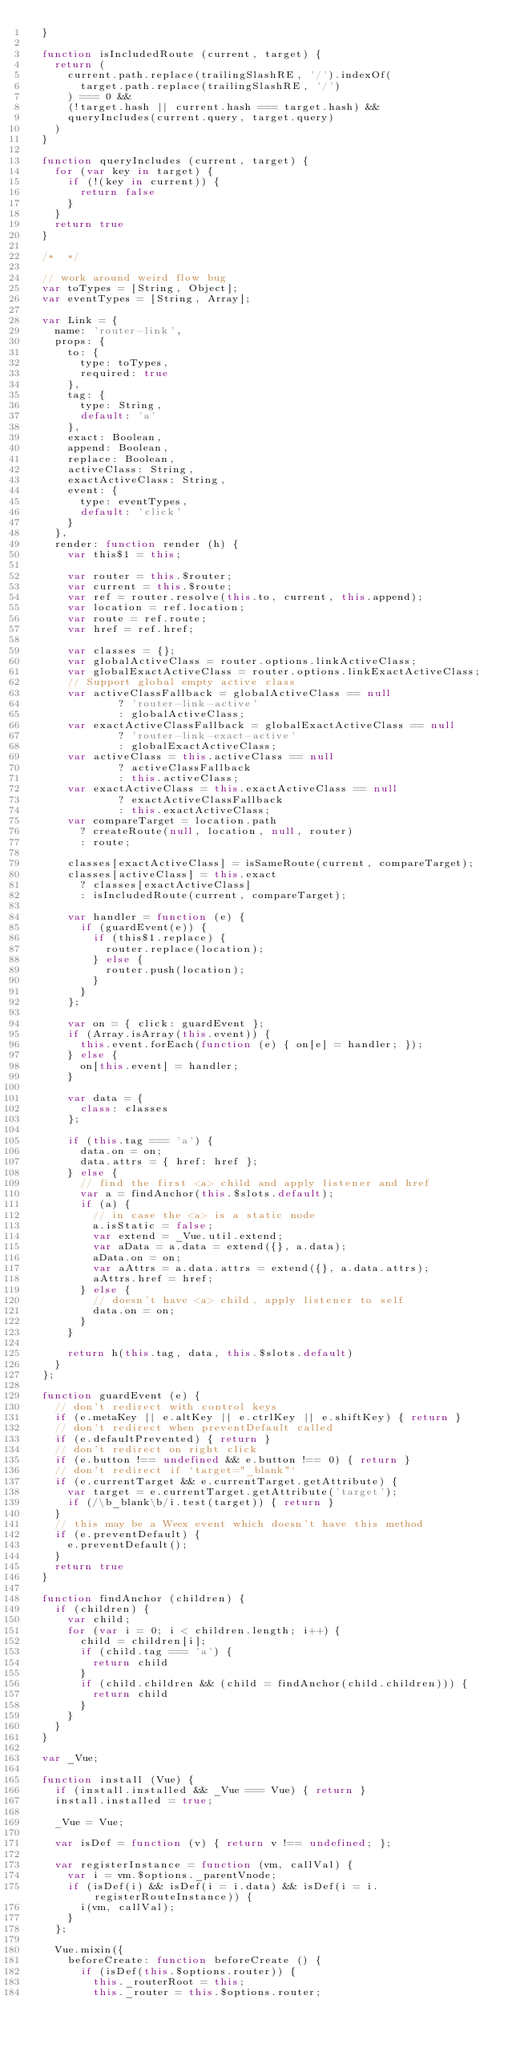<code> <loc_0><loc_0><loc_500><loc_500><_JavaScript_>  }
  
  function isIncludedRoute (current, target) {
    return (
      current.path.replace(trailingSlashRE, '/').indexOf(
        target.path.replace(trailingSlashRE, '/')
      ) === 0 &&
      (!target.hash || current.hash === target.hash) &&
      queryIncludes(current.query, target.query)
    )
  }
  
  function queryIncludes (current, target) {
    for (var key in target) {
      if (!(key in current)) {
        return false
      }
    }
    return true
  }
  
  /*  */
  
  // work around weird flow bug
  var toTypes = [String, Object];
  var eventTypes = [String, Array];
  
  var Link = {
    name: 'router-link',
    props: {
      to: {
        type: toTypes,
        required: true
      },
      tag: {
        type: String,
        default: 'a'
      },
      exact: Boolean,
      append: Boolean,
      replace: Boolean,
      activeClass: String,
      exactActiveClass: String,
      event: {
        type: eventTypes,
        default: 'click'
      }
    },
    render: function render (h) {
      var this$1 = this;
  
      var router = this.$router;
      var current = this.$route;
      var ref = router.resolve(this.to, current, this.append);
      var location = ref.location;
      var route = ref.route;
      var href = ref.href;
  
      var classes = {};
      var globalActiveClass = router.options.linkActiveClass;
      var globalExactActiveClass = router.options.linkExactActiveClass;
      // Support global empty active class
      var activeClassFallback = globalActiveClass == null
              ? 'router-link-active'
              : globalActiveClass;
      var exactActiveClassFallback = globalExactActiveClass == null
              ? 'router-link-exact-active'
              : globalExactActiveClass;
      var activeClass = this.activeClass == null
              ? activeClassFallback
              : this.activeClass;
      var exactActiveClass = this.exactActiveClass == null
              ? exactActiveClassFallback
              : this.exactActiveClass;
      var compareTarget = location.path
        ? createRoute(null, location, null, router)
        : route;
  
      classes[exactActiveClass] = isSameRoute(current, compareTarget);
      classes[activeClass] = this.exact
        ? classes[exactActiveClass]
        : isIncludedRoute(current, compareTarget);
  
      var handler = function (e) {
        if (guardEvent(e)) {
          if (this$1.replace) {
            router.replace(location);
          } else {
            router.push(location);
          }
        }
      };
  
      var on = { click: guardEvent };
      if (Array.isArray(this.event)) {
        this.event.forEach(function (e) { on[e] = handler; });
      } else {
        on[this.event] = handler;
      }
  
      var data = {
        class: classes
      };
  
      if (this.tag === 'a') {
        data.on = on;
        data.attrs = { href: href };
      } else {
        // find the first <a> child and apply listener and href
        var a = findAnchor(this.$slots.default);
        if (a) {
          // in case the <a> is a static node
          a.isStatic = false;
          var extend = _Vue.util.extend;
          var aData = a.data = extend({}, a.data);
          aData.on = on;
          var aAttrs = a.data.attrs = extend({}, a.data.attrs);
          aAttrs.href = href;
        } else {
          // doesn't have <a> child, apply listener to self
          data.on = on;
        }
      }
  
      return h(this.tag, data, this.$slots.default)
    }
  };
  
  function guardEvent (e) {
    // don't redirect with control keys
    if (e.metaKey || e.altKey || e.ctrlKey || e.shiftKey) { return }
    // don't redirect when preventDefault called
    if (e.defaultPrevented) { return }
    // don't redirect on right click
    if (e.button !== undefined && e.button !== 0) { return }
    // don't redirect if `target="_blank"`
    if (e.currentTarget && e.currentTarget.getAttribute) {
      var target = e.currentTarget.getAttribute('target');
      if (/\b_blank\b/i.test(target)) { return }
    }
    // this may be a Weex event which doesn't have this method
    if (e.preventDefault) {
      e.preventDefault();
    }
    return true
  }
  
  function findAnchor (children) {
    if (children) {
      var child;
      for (var i = 0; i < children.length; i++) {
        child = children[i];
        if (child.tag === 'a') {
          return child
        }
        if (child.children && (child = findAnchor(child.children))) {
          return child
        }
      }
    }
  }
  
  var _Vue;
  
  function install (Vue) {
    if (install.installed && _Vue === Vue) { return }
    install.installed = true;
  
    _Vue = Vue;
  
    var isDef = function (v) { return v !== undefined; };
  
    var registerInstance = function (vm, callVal) {
      var i = vm.$options._parentVnode;
      if (isDef(i) && isDef(i = i.data) && isDef(i = i.registerRouteInstance)) {
        i(vm, callVal);
      }
    };
  
    Vue.mixin({
      beforeCreate: function beforeCreate () {
        if (isDef(this.$options.router)) {
          this._routerRoot = this;
          this._router = this.$options.router;</code> 